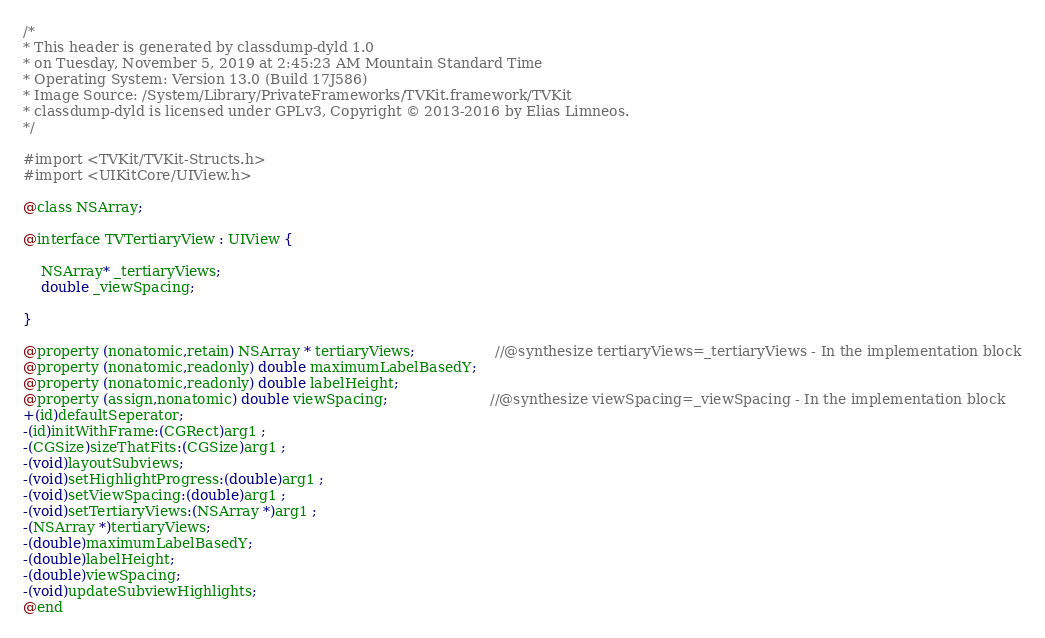Convert code to text. <code><loc_0><loc_0><loc_500><loc_500><_C_>/*
* This header is generated by classdump-dyld 1.0
* on Tuesday, November 5, 2019 at 2:45:23 AM Mountain Standard Time
* Operating System: Version 13.0 (Build 17J586)
* Image Source: /System/Library/PrivateFrameworks/TVKit.framework/TVKit
* classdump-dyld is licensed under GPLv3, Copyright © 2013-2016 by Elias Limneos.
*/

#import <TVKit/TVKit-Structs.h>
#import <UIKitCore/UIView.h>

@class NSArray;

@interface TVTertiaryView : UIView {

	NSArray* _tertiaryViews;
	double _viewSpacing;

}

@property (nonatomic,retain) NSArray * tertiaryViews;                  //@synthesize tertiaryViews=_tertiaryViews - In the implementation block
@property (nonatomic,readonly) double maximumLabelBasedY; 
@property (nonatomic,readonly) double labelHeight; 
@property (assign,nonatomic) double viewSpacing;                       //@synthesize viewSpacing=_viewSpacing - In the implementation block
+(id)defaultSeperator;
-(id)initWithFrame:(CGRect)arg1 ;
-(CGSize)sizeThatFits:(CGSize)arg1 ;
-(void)layoutSubviews;
-(void)setHighlightProgress:(double)arg1 ;
-(void)setViewSpacing:(double)arg1 ;
-(void)setTertiaryViews:(NSArray *)arg1 ;
-(NSArray *)tertiaryViews;
-(double)maximumLabelBasedY;
-(double)labelHeight;
-(double)viewSpacing;
-(void)updateSubviewHighlights;
@end

</code> 